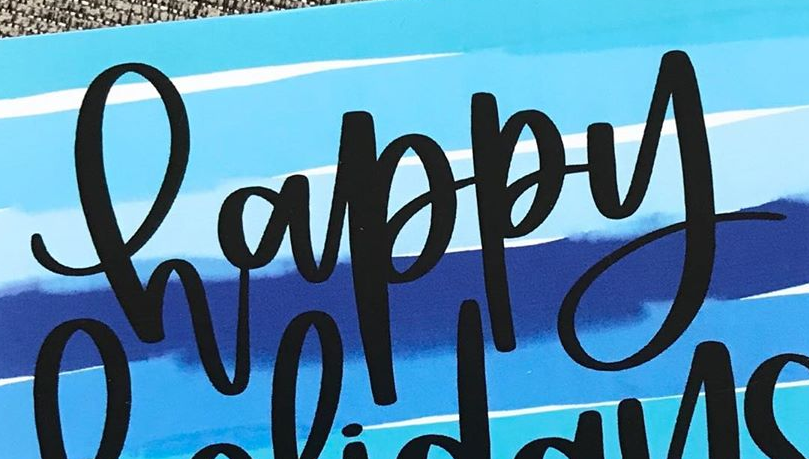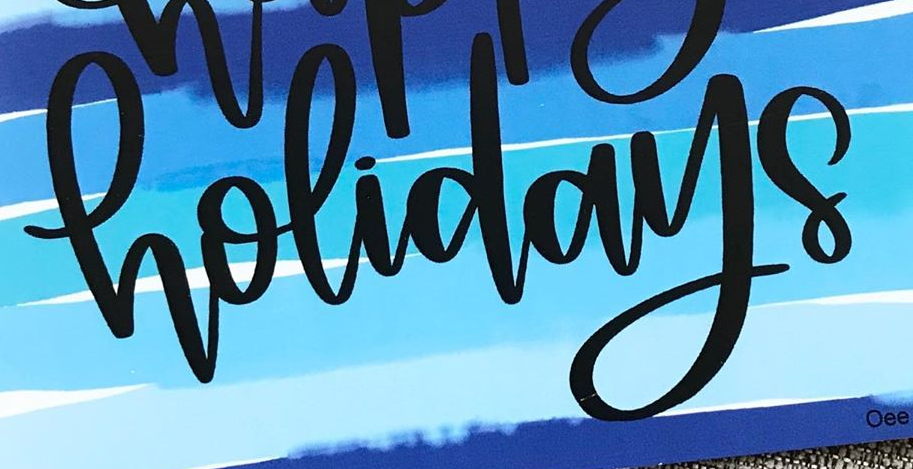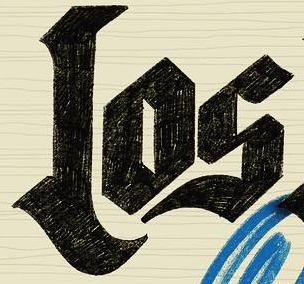Read the text content from these images in order, separated by a semicolon. happy; holidays; Los 